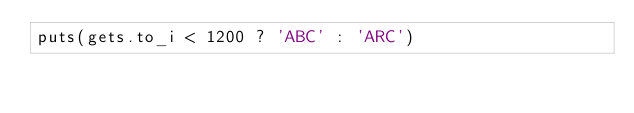Convert code to text. <code><loc_0><loc_0><loc_500><loc_500><_Ruby_>puts(gets.to_i < 1200 ? 'ABC' : 'ARC')</code> 